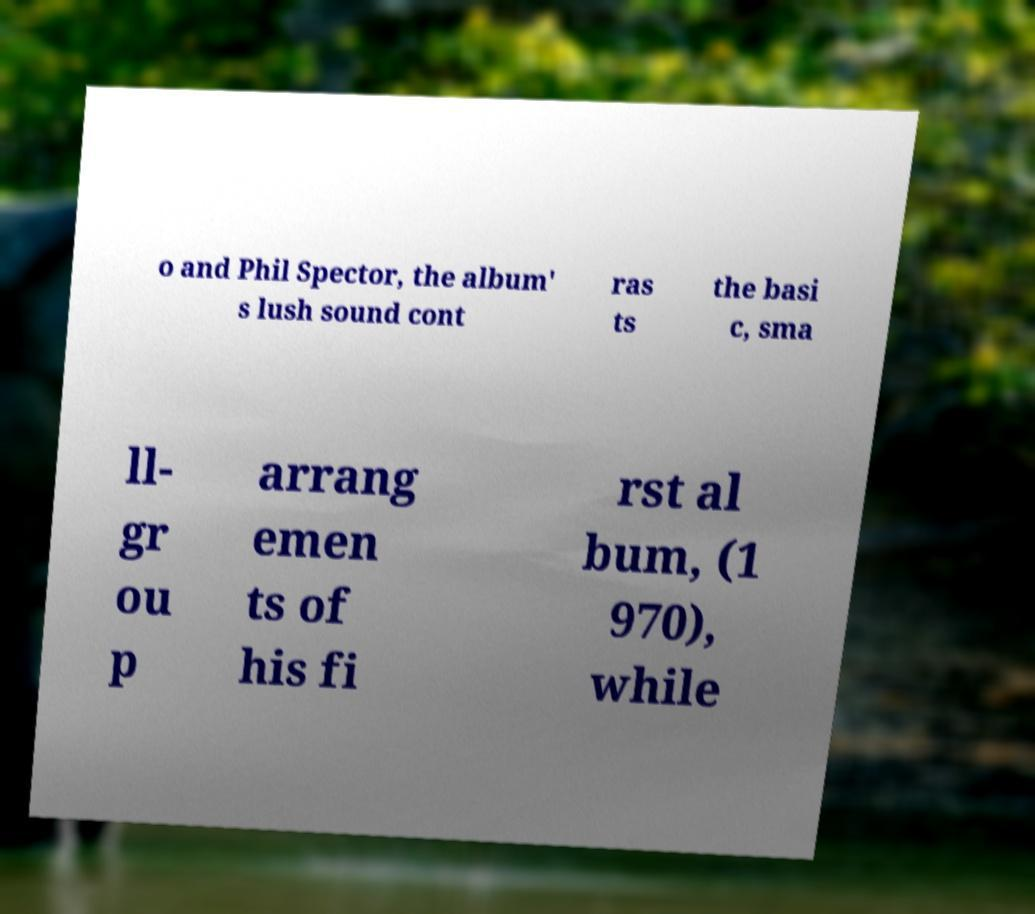Could you assist in decoding the text presented in this image and type it out clearly? o and Phil Spector, the album' s lush sound cont ras ts the basi c, sma ll- gr ou p arrang emen ts of his fi rst al bum, (1 970), while 